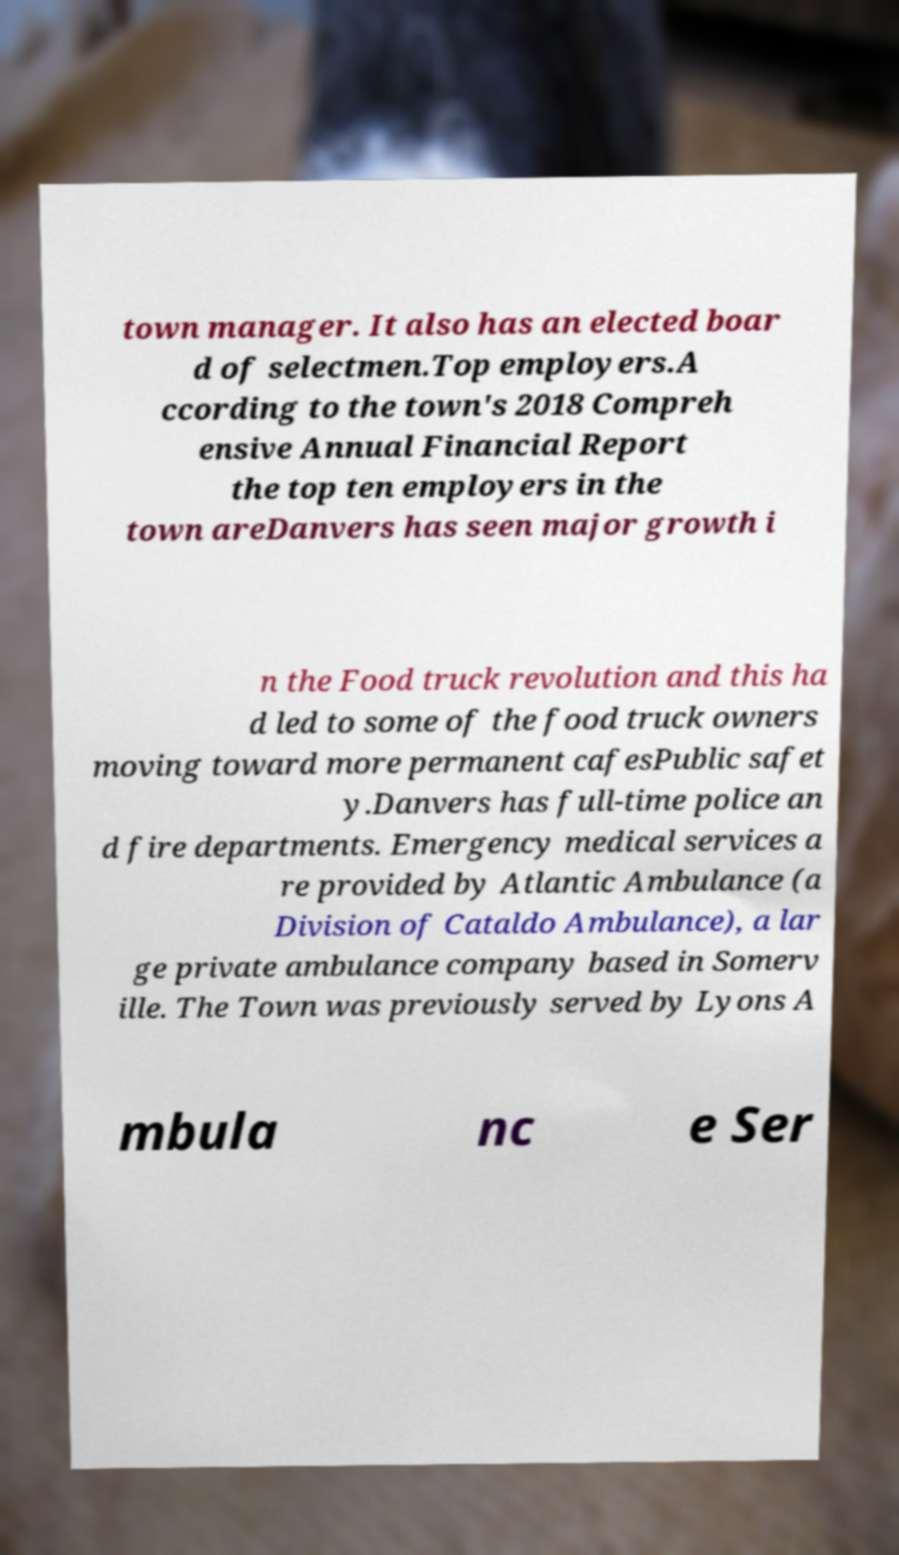There's text embedded in this image that I need extracted. Can you transcribe it verbatim? town manager. It also has an elected boar d of selectmen.Top employers.A ccording to the town's 2018 Compreh ensive Annual Financial Report the top ten employers in the town areDanvers has seen major growth i n the Food truck revolution and this ha d led to some of the food truck owners moving toward more permanent cafesPublic safet y.Danvers has full-time police an d fire departments. Emergency medical services a re provided by Atlantic Ambulance (a Division of Cataldo Ambulance), a lar ge private ambulance company based in Somerv ille. The Town was previously served by Lyons A mbula nc e Ser 